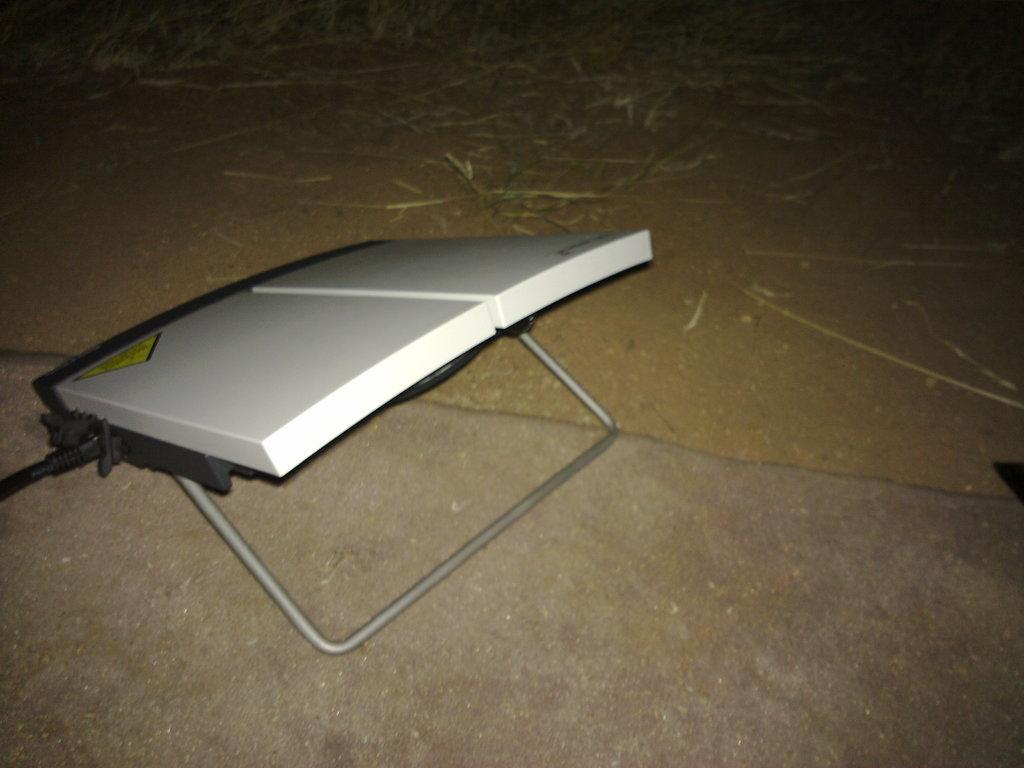What type of structure is in the image? There is a plastic stand with a metal base in the image. Where is the stand located? The stand is on the land. What type of material is present on the ground? There is dry straw on a sand floor. Can you find the receipt for the purchase of the cart in the image? There is no receipt or cart present in the image. Is there a coach visible in the image? There is no coach present in the image. 